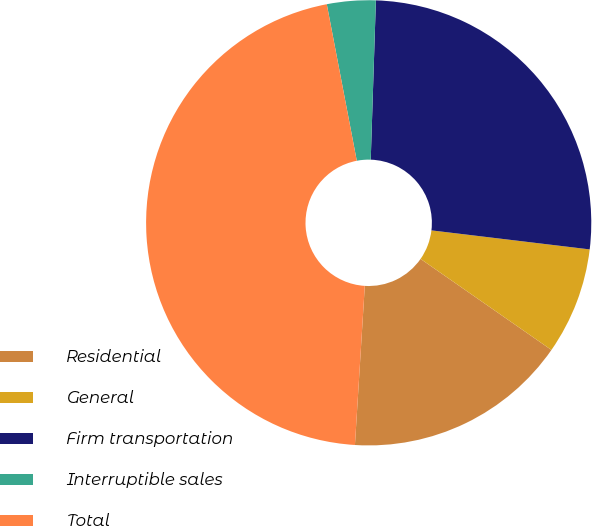<chart> <loc_0><loc_0><loc_500><loc_500><pie_chart><fcel>Residential<fcel>General<fcel>Firm transportation<fcel>Interruptible sales<fcel>Total<nl><fcel>16.31%<fcel>7.77%<fcel>26.39%<fcel>3.53%<fcel>46.0%<nl></chart> 